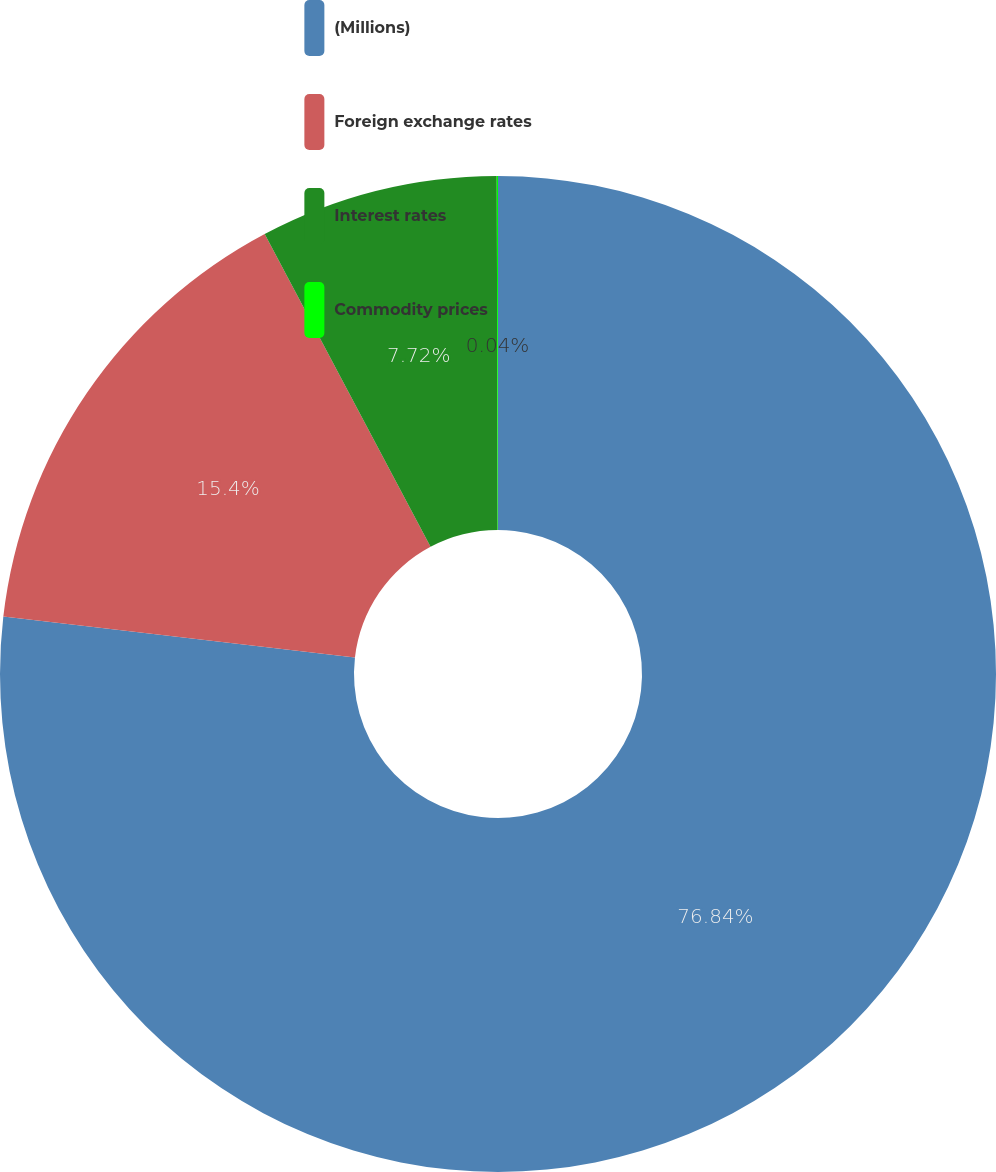Convert chart to OTSL. <chart><loc_0><loc_0><loc_500><loc_500><pie_chart><fcel>(Millions)<fcel>Foreign exchange rates<fcel>Interest rates<fcel>Commodity prices<nl><fcel>76.84%<fcel>15.4%<fcel>7.72%<fcel>0.04%<nl></chart> 